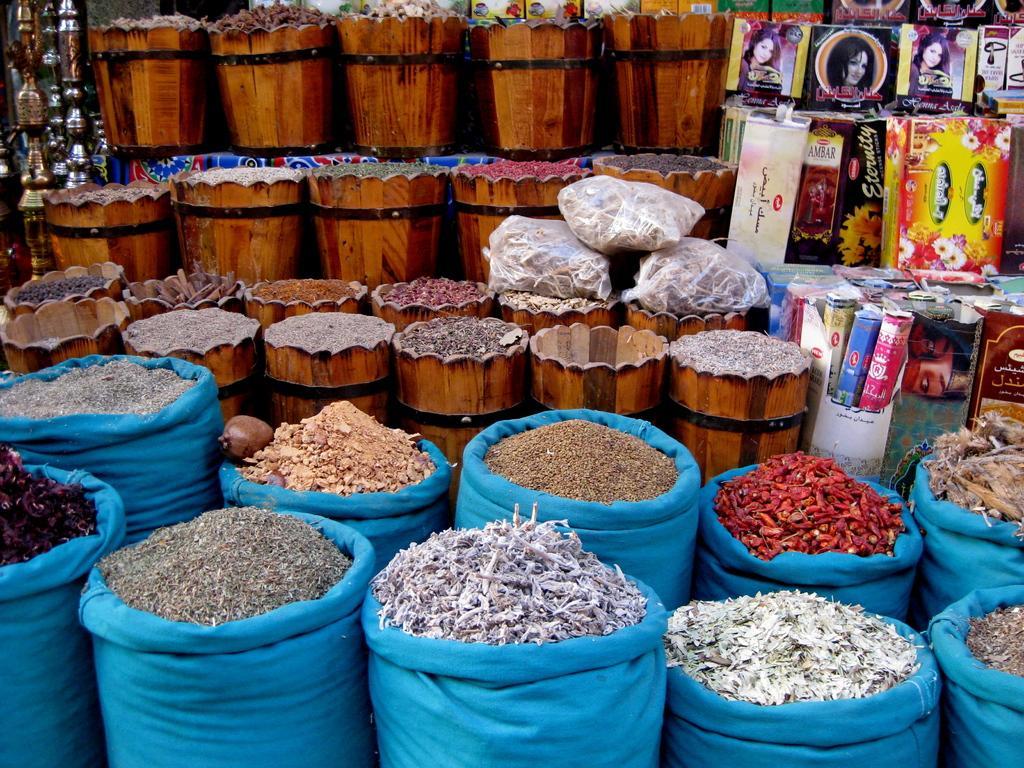Please provide a concise description of this image. This picture seems to be clicked inside. In the foreground we can see the blue color bags containing some spices and other food items. In the center we can see the wooden objects containing some items. On the right corner we can see the boxes of some products and we can see the pictures of persons on the boxes and we can see the text on the boxes. On the left corner we can see the metal objects. At the top we can see the wooden objects containing many number of items. 